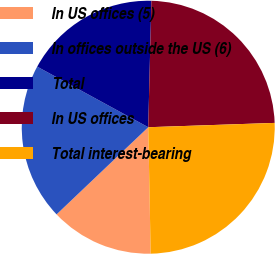Convert chart to OTSL. <chart><loc_0><loc_0><loc_500><loc_500><pie_chart><fcel>In US offices (5)<fcel>In offices outside the US (6)<fcel>Total<fcel>In US offices<fcel>Total interest-bearing<nl><fcel>13.21%<fcel>20.05%<fcel>17.45%<fcel>24.06%<fcel>25.24%<nl></chart> 